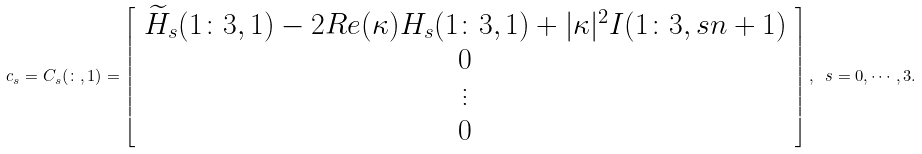Convert formula to latex. <formula><loc_0><loc_0><loc_500><loc_500>c _ { s } = C _ { s } ( \colon , 1 ) = \left [ \begin{array} { c } \widetilde { H } _ { s } ( 1 \colon 3 , 1 ) - 2 R e ( \kappa ) H _ { s } ( 1 \colon 3 , 1 ) + | \kappa | ^ { 2 } I ( 1 \colon 3 , s n + 1 ) \\ 0 \\ \vdots \\ 0 \\ \end{array} \right ] , \ s = 0 , \cdots , 3 .</formula> 